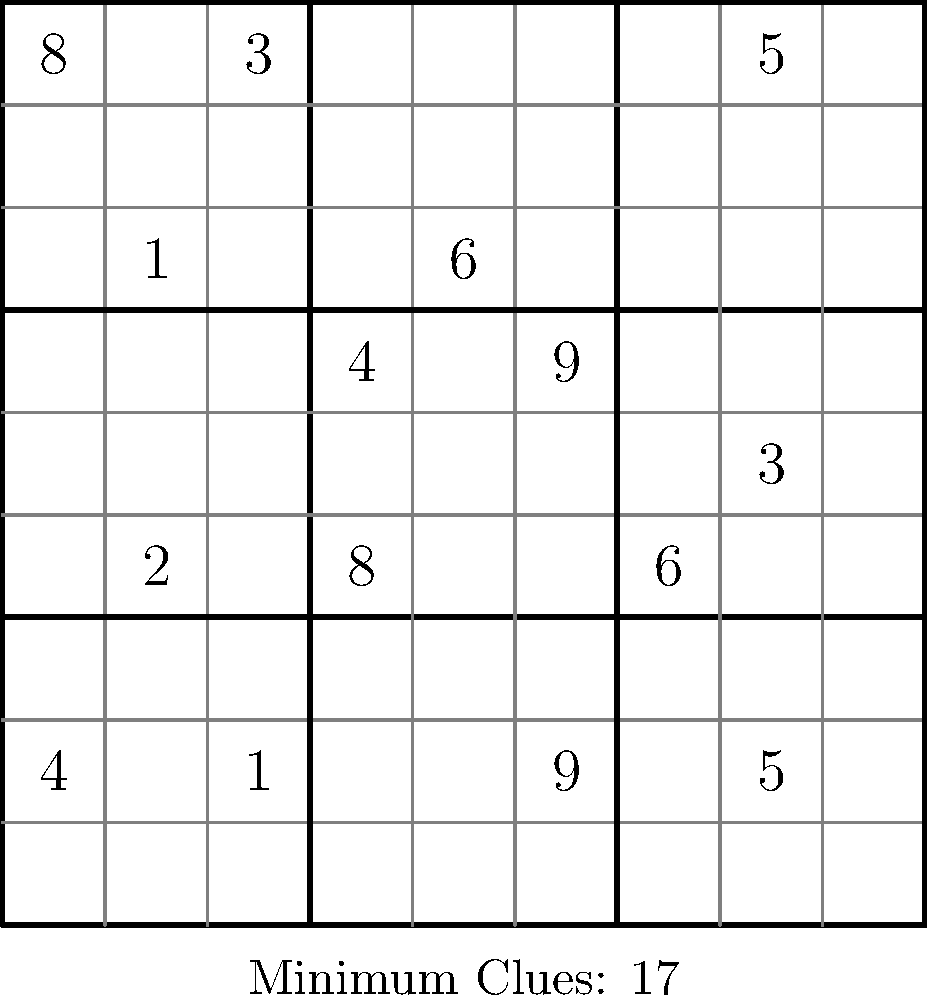In your role as a Sudoku puzzle designer, you're researching the concept of minimal Sudoku puzzles. Given that the image shows a Sudoku puzzle with the minimum number of clues needed for a unique solution, how many possible unique Sudoku grids (completed solutions) exist for a standard 9x9 puzzle, and how does this relate to the minimum number of clues shown? To answer this question, let's break it down step-by-step:

1. The image shows a Sudoku puzzle with 17 given clues, which is the minimum number of clues needed to ensure a unique solution in a 9x9 Sudoku puzzle.

2. The total number of possible completed 9x9 Sudoku grids is a fixed value, regardless of the number of initial clues. This number has been calculated to be approximately $6.67 \times 10^{21}$.

3. The relationship between the number of unique grids and the minimum number of clues is complex:
   a) With 16 or fewer clues, it's impossible to guarantee a unique solution.
   b) With 17 clues, it becomes possible to create puzzles with a unique solution, but not for all possible completed grids.
   c) As the number of clues increases beyond 17, more completed grids can be uniquely determined.

4. The minimum of 17 clues represents a tipping point where:
   - It's possible to uniquely determine at least one completed grid.
   - It's impossible to uniquely determine all possible completed grids.

5. This minimum number of clues (17) is significantly smaller than the total number of cells in a 9x9 grid (81), demonstrating the power of logical deduction in Sudoku solving.

6. The vast number of possible completed grids ($6.67 \times 10^{21}$) compared to the relatively small number of minimum clues (17) highlights the complexity and richness of Sudoku as a logical puzzle.

This relationship underscores why Sudoku is considered a superior logic-based puzzle: it offers an enormous number of possible solutions while requiring relatively few initial clues to create a challenging and uniquely solvable puzzle.
Answer: $6.67 \times 10^{21}$ unique grids; 17 clues enable unique solutions for some, but not all, possible grids. 